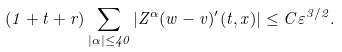Convert formula to latex. <formula><loc_0><loc_0><loc_500><loc_500>( 1 + t + r ) \sum _ { | \alpha | \leq 4 0 } | Z ^ { \alpha } ( w - v ) ^ { \prime } ( t , x ) | \leq C \varepsilon ^ { 3 / 2 } .</formula> 